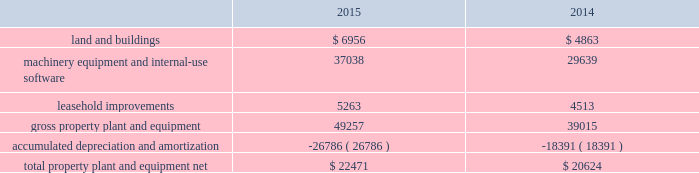Table of contents the notional amounts for outstanding derivative instruments provide one measure of the transaction volume outstanding and do not represent the amount of the company 2019s exposure to credit or market loss .
The credit risk amounts represent the company 2019s gross exposure to potential accounting loss on derivative instruments that are outstanding or unsettled if all counterparties failed to perform according to the terms of the contract , based on then-current currency or interest rates at each respective date .
The company 2019s exposure to credit loss and market risk will vary over time as currency and interest rates change .
Although the table above reflects the notional and credit risk amounts of the company 2019s derivative instruments , it does not reflect the gains or losses associated with the exposures and transactions that the instruments are intended to hedge .
The amounts ultimately realized upon settlement of these financial instruments , together with the gains and losses on the underlying exposures , will depend on actual market conditions during the remaining life of the instruments .
The company generally enters into master netting arrangements , which are designed to reduce credit risk by permitting net settlement of transactions with the same counterparty .
To further limit credit risk , the company generally enters into collateral security arrangements that provide for collateral to be received or posted when the net fair value of certain financial instruments fluctuates from contractually established thresholds .
The company presents its derivative assets and derivative liabilities at their gross fair values in its consolidated balance sheets .
The net cash collateral received by the company related to derivative instruments under its collateral security arrangements was $ 1.0 billion as of september 26 , 2015 and $ 2.1 billion as of september 27 , 2014 .
Under master netting arrangements with the respective counterparties to the company 2019s derivative contracts , the company is allowed to net settle transactions with a single net amount payable by one party to the other .
As of september 26 , 2015 and september 27 , 2014 , the potential effects of these rights of set-off associated with the company 2019s derivative contracts , including the effects of collateral , would be a reduction to both derivative assets and derivative liabilities of $ 2.2 billion and $ 1.6 billion , respectively , resulting in net derivative liabilities of $ 78 million and $ 549 million , respectively .
Accounts receivable receivables the company has considerable trade receivables outstanding with its third-party cellular network carriers , wholesalers , retailers , value-added resellers , small and mid-sized businesses and education , enterprise and government customers .
The company generally does not require collateral from its customers ; however , the company will require collateral in certain instances to limit credit risk .
In addition , when possible , the company attempts to limit credit risk on trade receivables with credit insurance for certain customers or by requiring third-party financing , loans or leases to support credit exposure .
These credit-financing arrangements are directly between the third-party financing company and the end customer .
As such , the company generally does not assume any recourse or credit risk sharing related to any of these arrangements .
As of september 26 , 2015 , the company had one customer that represented 10% ( 10 % ) or more of total trade receivables , which accounted for 12% ( 12 % ) .
As of september 27 , 2014 , the company had two customers that represented 10% ( 10 % ) or more of total trade receivables , one of which accounted for 16% ( 16 % ) and the other 13% ( 13 % ) .
The company 2019s cellular network carriers accounted for 71% ( 71 % ) and 72% ( 72 % ) of trade receivables as of september 26 , 2015 and september 27 , 2014 , respectively .
Vendor non-trade receivables the company has non-trade receivables from certain of its manufacturing vendors resulting from the sale of components to these vendors who manufacture sub-assemblies or assemble final products for the company .
The company purchases these components directly from suppliers .
Vendor non-trade receivables from three of the company 2019s vendors accounted for 38% ( 38 % ) , 18% ( 18 % ) and 14% ( 14 % ) of total vendor non-trade receivables as of september 26 , 2015 and three of the company 2019s vendors accounted for 51% ( 51 % ) , 16% ( 16 % ) and 14% ( 14 % ) of total vendor non-trade receivables as of september 27 , 2014 .
Note 3 2013 consolidated financial statement details the tables show the company 2019s consolidated financial statement details as of september 26 , 2015 and september 27 , 2014 ( in millions ) : property , plant and equipment , net .
Apple inc .
| 2015 form 10-k | 53 .
What is the net change in total property plant and equipment net from 2014 to 2015 in millions? 
Computations: (22471 - 20624)
Answer: 1847.0. 